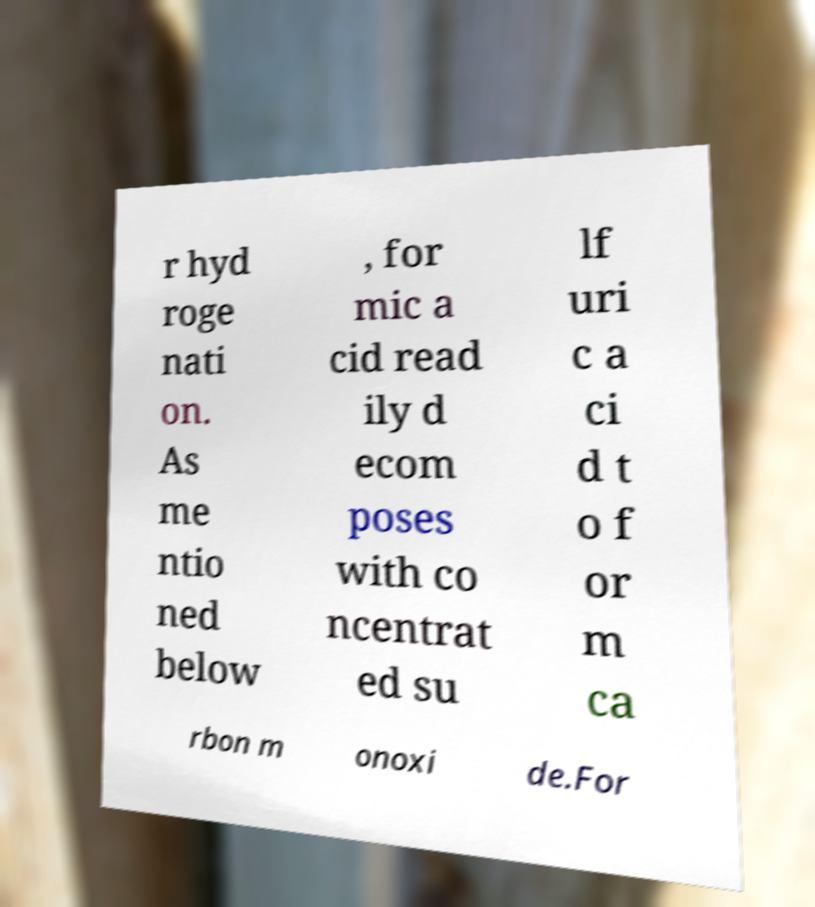Could you extract and type out the text from this image? r hyd roge nati on. As me ntio ned below , for mic a cid read ily d ecom poses with co ncentrat ed su lf uri c a ci d t o f or m ca rbon m onoxi de.For 